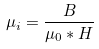<formula> <loc_0><loc_0><loc_500><loc_500>\mu _ { i } = \frac { B } { \mu _ { 0 } * H }</formula> 